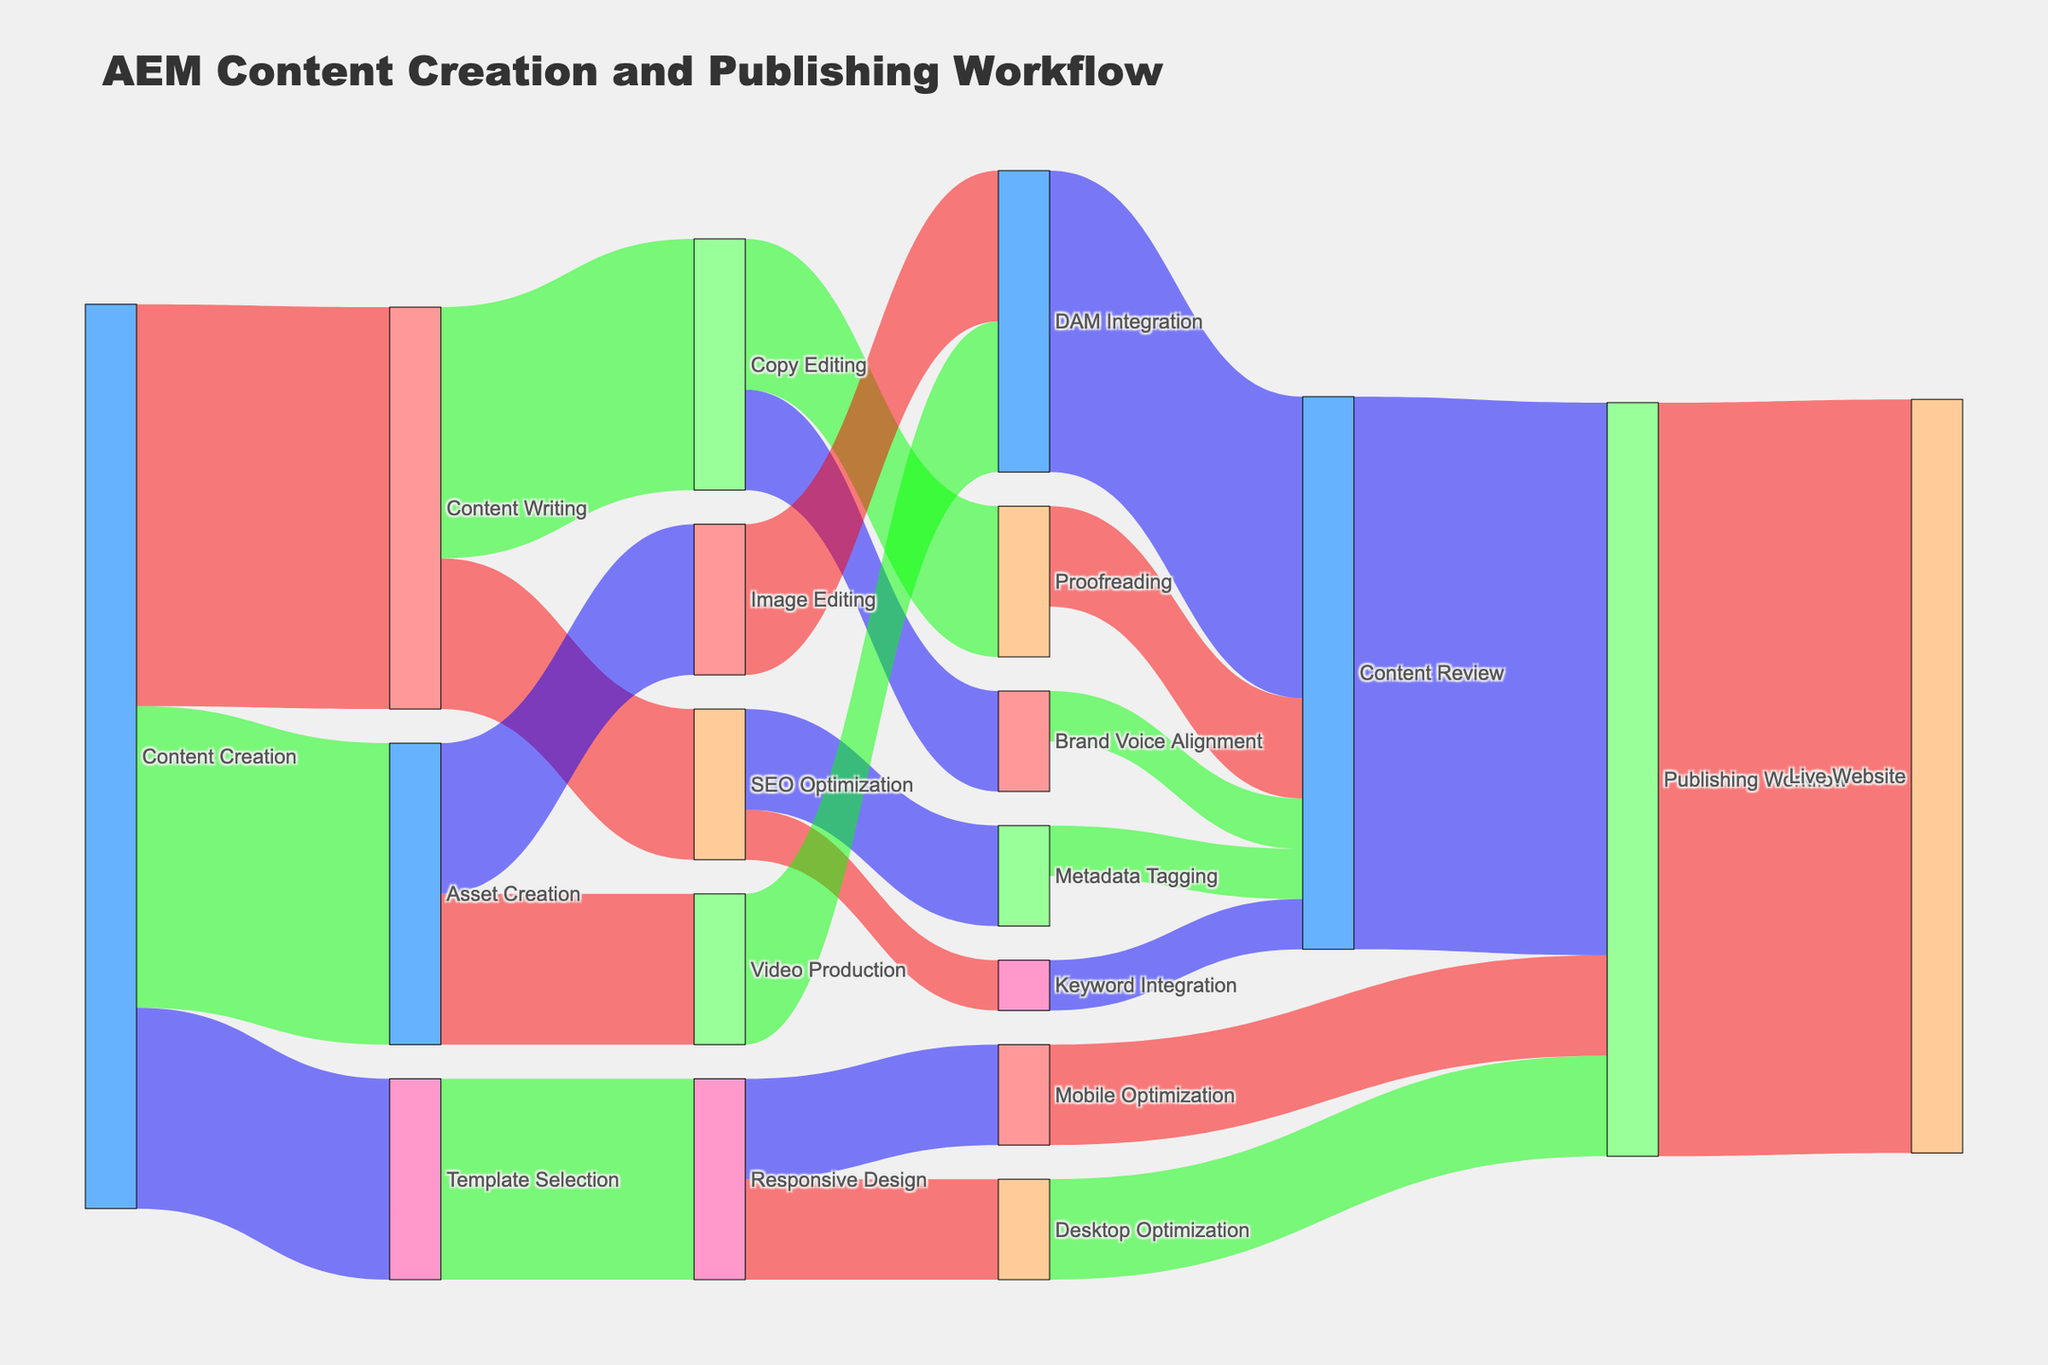What is the title of the diagram? The title of the diagram is shown at the top and reads "AEM Content Creation and Publishing Workflow."
Answer: AEM Content Creation and Publishing Workflow What phase has the highest outflow from Content Creation? The diagram shows the connections from Content Creation, and the highest value is 40, leading to Content Writing.
Answer: Content Writing How many total connections target Content Review? Count all the connections that have Content Review as the target. These are from Metadata Tagging (5), Keyword Integration (5), Proofreading (10), Brand Voice Alignment (5), and DAM Integration (30), which add up to 55.
Answer: 5 Which phases in the diagram involve DAM Integration? Look for nodes connected to and from DAM Integration. They are Asset Creation, Image Editing, and Video Production.
Answer: Asset Creation, Image Editing, Video Production Where does Content Review lead in the workflow? The flow from Content Review is directed towards Publishing Workflow.
Answer: Publishing Workflow What's the total value entering Publishing Workflow? Sum the values leading into Publishing Workflow. These are Mobile Optimization (10), Desktop Optimization (10), and Content Review (55), for a total of 75.
Answer: 75 How does SEO Optimization break down its flow? SEO Optimization flows into Metadata Tagging (10) and Keyword Integration (5).
Answer: Metadata Tagging, Keyword Integration Which element does not appear to lead into Responsive Design? Examine all the connections leading into Responsive Design. None come from Content Creation, Content Writing, or any subsequent phases in those paths.
Answer: Content Creation, Content Writing Is there more effort allocated to Content Writing or Asset Creation? Compare the values flowing into Content Writing (40) and Asset Creation (30).
Answer: Content Writing Which final phase receives the most input and what is the value? The final phases are considerd as those without any further outflows. Live Website receives the most input from Publishing Workflow with a value of 75.
Answer: Live Website, 75 